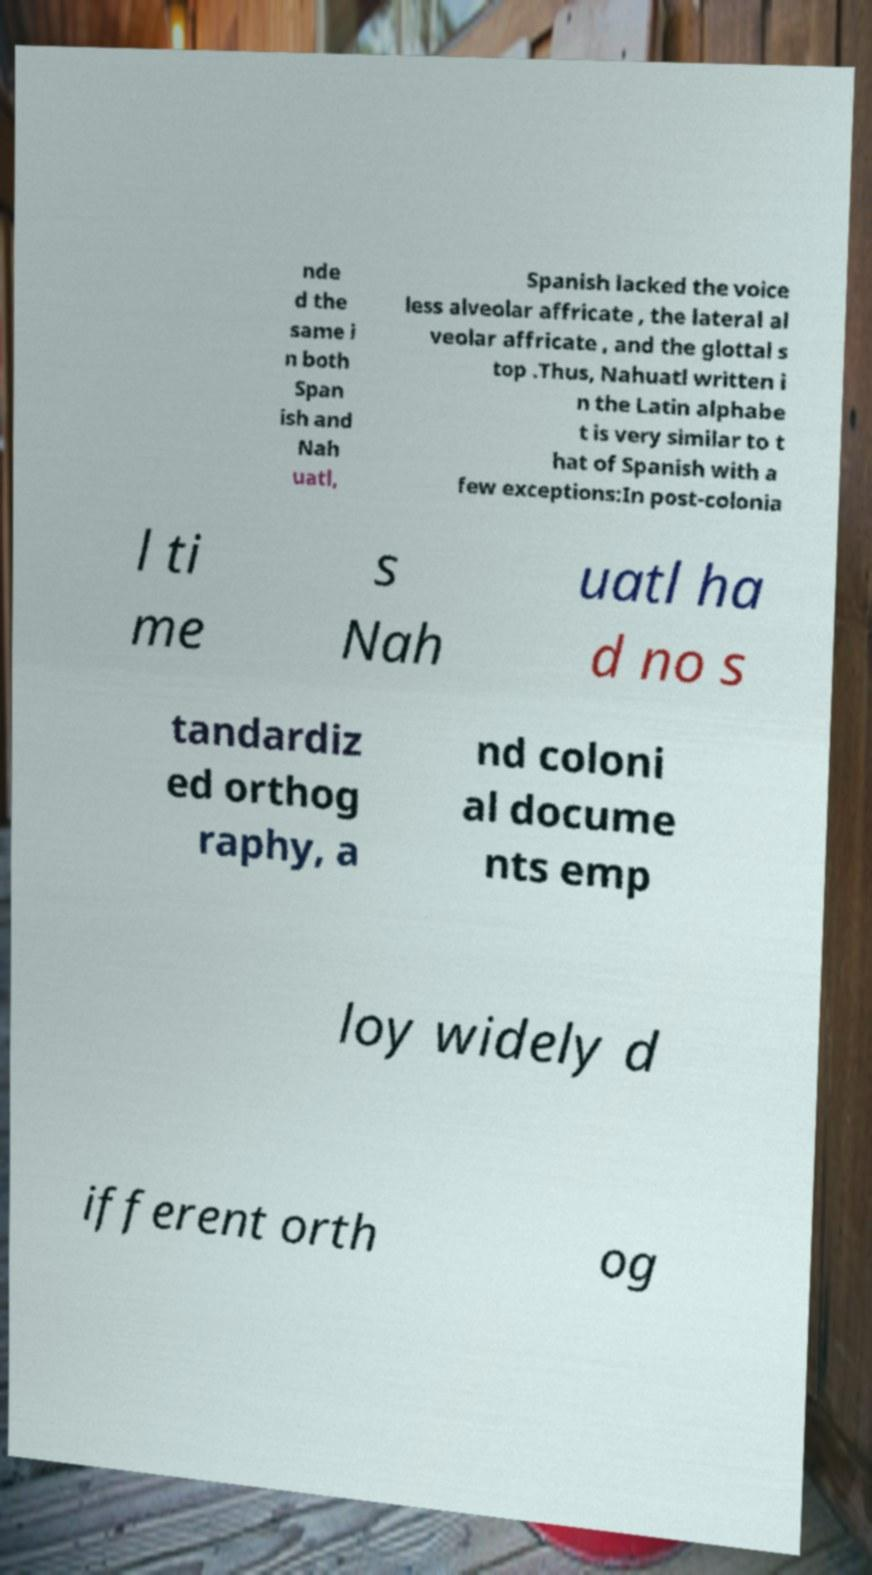What messages or text are displayed in this image? I need them in a readable, typed format. nde d the same i n both Span ish and Nah uatl, Spanish lacked the voice less alveolar affricate , the lateral al veolar affricate , and the glottal s top .Thus, Nahuatl written i n the Latin alphabe t is very similar to t hat of Spanish with a few exceptions:In post-colonia l ti me s Nah uatl ha d no s tandardiz ed orthog raphy, a nd coloni al docume nts emp loy widely d ifferent orth og 